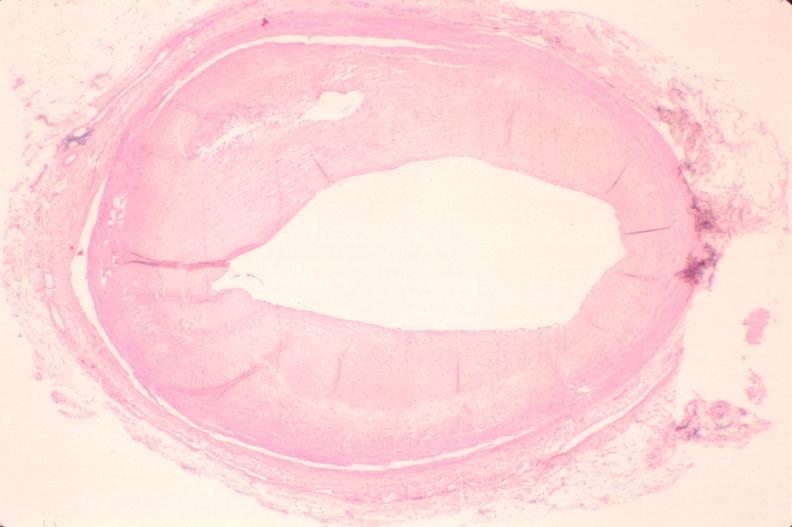how is atherosclerosis left anterior descending artery?
Answer the question using a single word or phrase. Coronary 